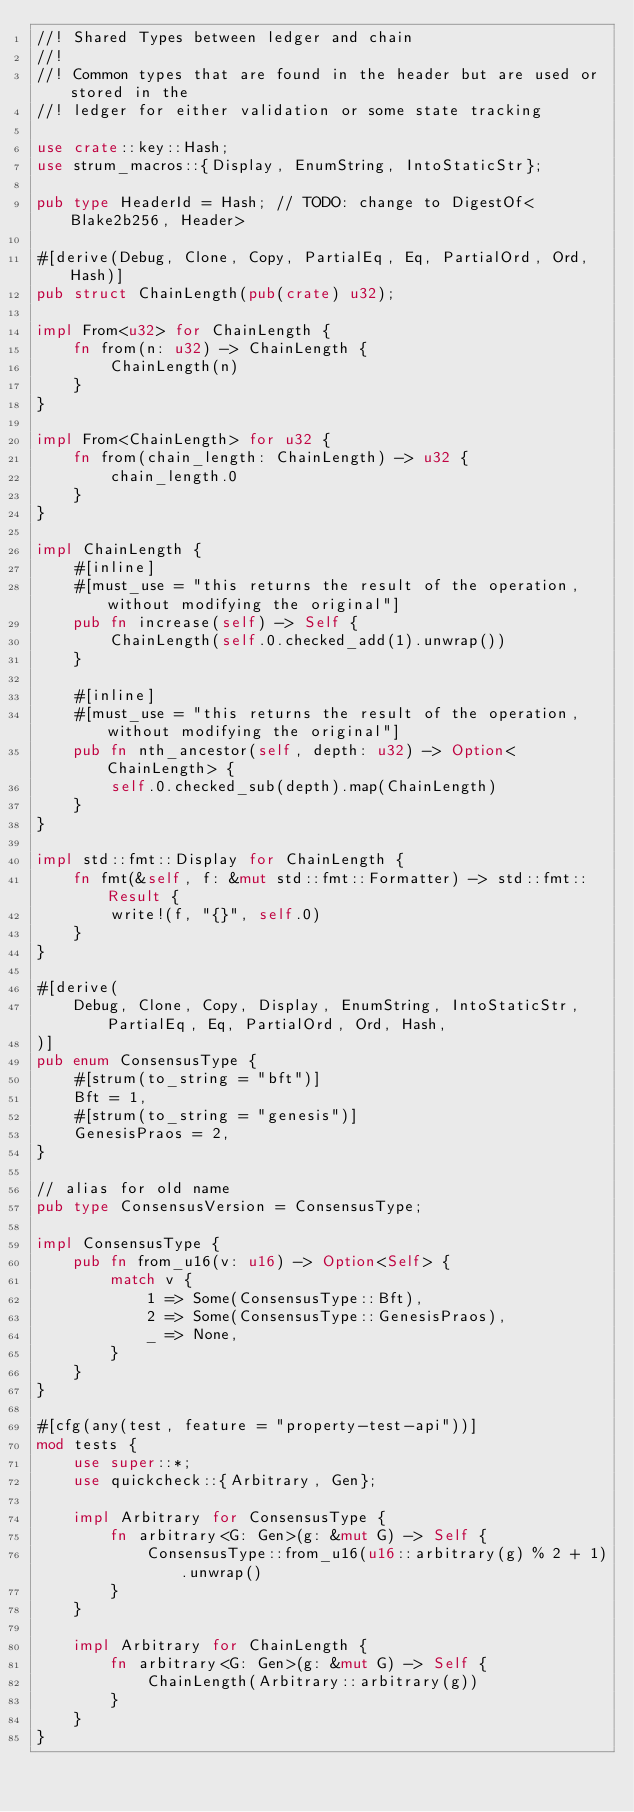Convert code to text. <code><loc_0><loc_0><loc_500><loc_500><_Rust_>//! Shared Types between ledger and chain
//!
//! Common types that are found in the header but are used or stored in the
//! ledger for either validation or some state tracking

use crate::key::Hash;
use strum_macros::{Display, EnumString, IntoStaticStr};

pub type HeaderId = Hash; // TODO: change to DigestOf<Blake2b256, Header>

#[derive(Debug, Clone, Copy, PartialEq, Eq, PartialOrd, Ord, Hash)]
pub struct ChainLength(pub(crate) u32);

impl From<u32> for ChainLength {
    fn from(n: u32) -> ChainLength {
        ChainLength(n)
    }
}

impl From<ChainLength> for u32 {
    fn from(chain_length: ChainLength) -> u32 {
        chain_length.0
    }
}

impl ChainLength {
    #[inline]
    #[must_use = "this returns the result of the operation, without modifying the original"]
    pub fn increase(self) -> Self {
        ChainLength(self.0.checked_add(1).unwrap())
    }

    #[inline]
    #[must_use = "this returns the result of the operation, without modifying the original"]
    pub fn nth_ancestor(self, depth: u32) -> Option<ChainLength> {
        self.0.checked_sub(depth).map(ChainLength)
    }
}

impl std::fmt::Display for ChainLength {
    fn fmt(&self, f: &mut std::fmt::Formatter) -> std::fmt::Result {
        write!(f, "{}", self.0)
    }
}

#[derive(
    Debug, Clone, Copy, Display, EnumString, IntoStaticStr, PartialEq, Eq, PartialOrd, Ord, Hash,
)]
pub enum ConsensusType {
    #[strum(to_string = "bft")]
    Bft = 1,
    #[strum(to_string = "genesis")]
    GenesisPraos = 2,
}

// alias for old name
pub type ConsensusVersion = ConsensusType;

impl ConsensusType {
    pub fn from_u16(v: u16) -> Option<Self> {
        match v {
            1 => Some(ConsensusType::Bft),
            2 => Some(ConsensusType::GenesisPraos),
            _ => None,
        }
    }
}

#[cfg(any(test, feature = "property-test-api"))]
mod tests {
    use super::*;
    use quickcheck::{Arbitrary, Gen};

    impl Arbitrary for ConsensusType {
        fn arbitrary<G: Gen>(g: &mut G) -> Self {
            ConsensusType::from_u16(u16::arbitrary(g) % 2 + 1).unwrap()
        }
    }

    impl Arbitrary for ChainLength {
        fn arbitrary<G: Gen>(g: &mut G) -> Self {
            ChainLength(Arbitrary::arbitrary(g))
        }
    }
}
</code> 